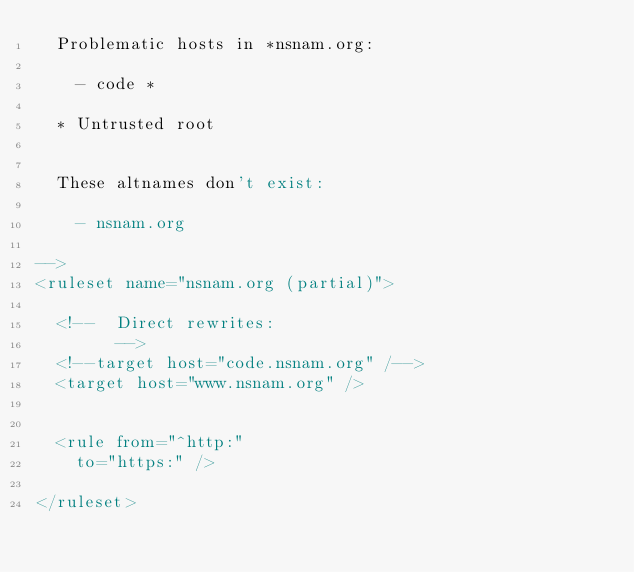<code> <loc_0><loc_0><loc_500><loc_500><_XML_>	Problematic hosts in *nsnam.org:

		- code *

	* Untrusted root


	These altnames don't exist:

		- nsnam.org

-->
<ruleset name="nsnam.org (partial)">

	<!--	Direct rewrites:
				-->
	<!--target host="code.nsnam.org" /-->
	<target host="www.nsnam.org" />


	<rule from="^http:"
		to="https:" />

</ruleset>
</code> 